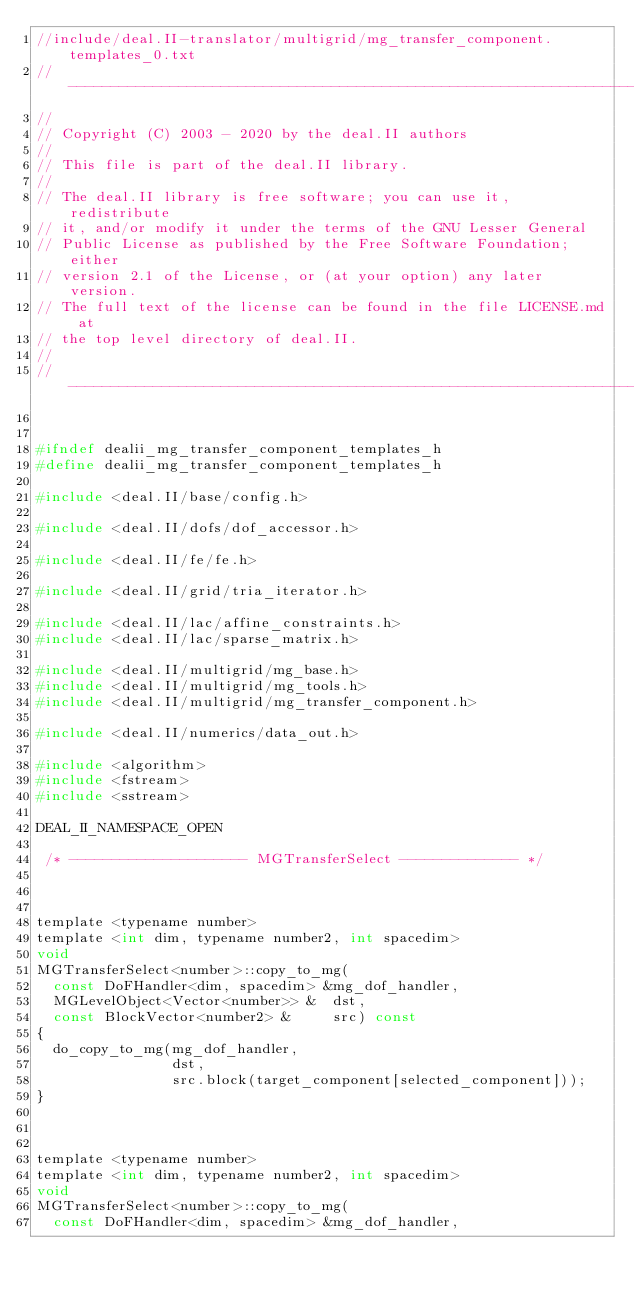<code> <loc_0><loc_0><loc_500><loc_500><_C_>//include/deal.II-translator/multigrid/mg_transfer_component.templates_0.txt
// ---------------------------------------------------------------------
//
// Copyright (C) 2003 - 2020 by the deal.II authors
//
// This file is part of the deal.II library.
//
// The deal.II library is free software; you can use it, redistribute
// it, and/or modify it under the terms of the GNU Lesser General
// Public License as published by the Free Software Foundation; either
// version 2.1 of the License, or (at your option) any later version.
// The full text of the license can be found in the file LICENSE.md at
// the top level directory of deal.II.
//
// ---------------------------------------------------------------------


#ifndef dealii_mg_transfer_component_templates_h
#define dealii_mg_transfer_component_templates_h

#include <deal.II/base/config.h>

#include <deal.II/dofs/dof_accessor.h>

#include <deal.II/fe/fe.h>

#include <deal.II/grid/tria_iterator.h>

#include <deal.II/lac/affine_constraints.h>
#include <deal.II/lac/sparse_matrix.h>

#include <deal.II/multigrid/mg_base.h>
#include <deal.II/multigrid/mg_tools.h>
#include <deal.II/multigrid/mg_transfer_component.h>

#include <deal.II/numerics/data_out.h>

#include <algorithm>
#include <fstream>
#include <sstream>

DEAL_II_NAMESPACE_OPEN

 /* --------------------- MGTransferSelect -------------- */ 



template <typename number>
template <int dim, typename number2, int spacedim>
void
MGTransferSelect<number>::copy_to_mg(
  const DoFHandler<dim, spacedim> &mg_dof_handler,
  MGLevelObject<Vector<number>> &  dst,
  const BlockVector<number2> &     src) const
{
  do_copy_to_mg(mg_dof_handler,
                dst,
                src.block(target_component[selected_component]));
}



template <typename number>
template <int dim, typename number2, int spacedim>
void
MGTransferSelect<number>::copy_to_mg(
  const DoFHandler<dim, spacedim> &mg_dof_handler,</code> 